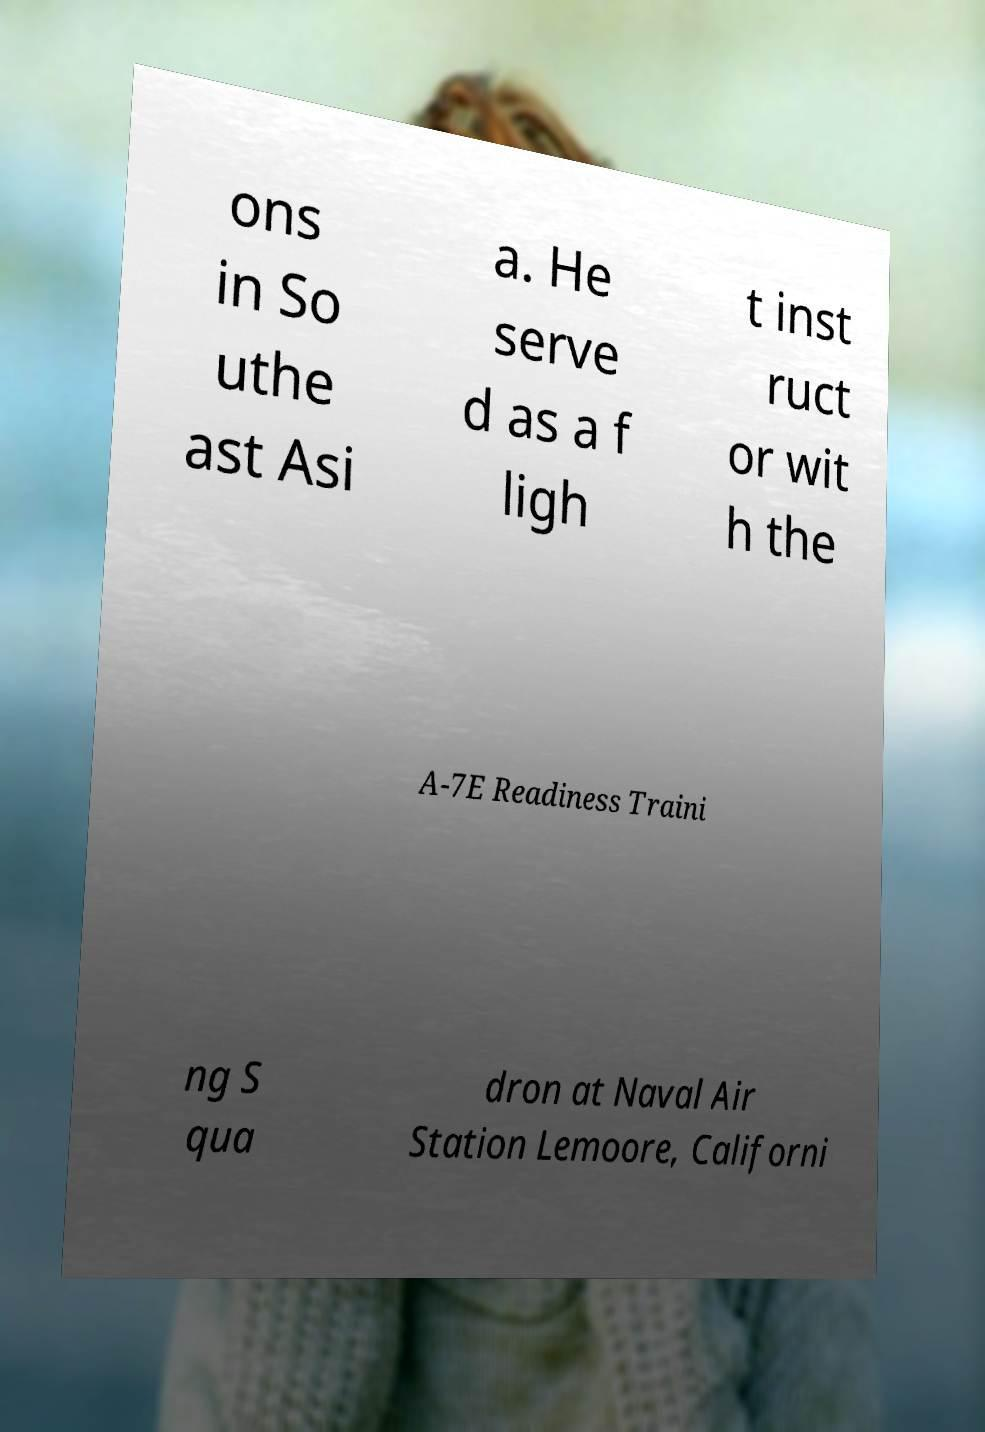Can you read and provide the text displayed in the image?This photo seems to have some interesting text. Can you extract and type it out for me? ons in So uthe ast Asi a. He serve d as a f ligh t inst ruct or wit h the A-7E Readiness Traini ng S qua dron at Naval Air Station Lemoore, Californi 